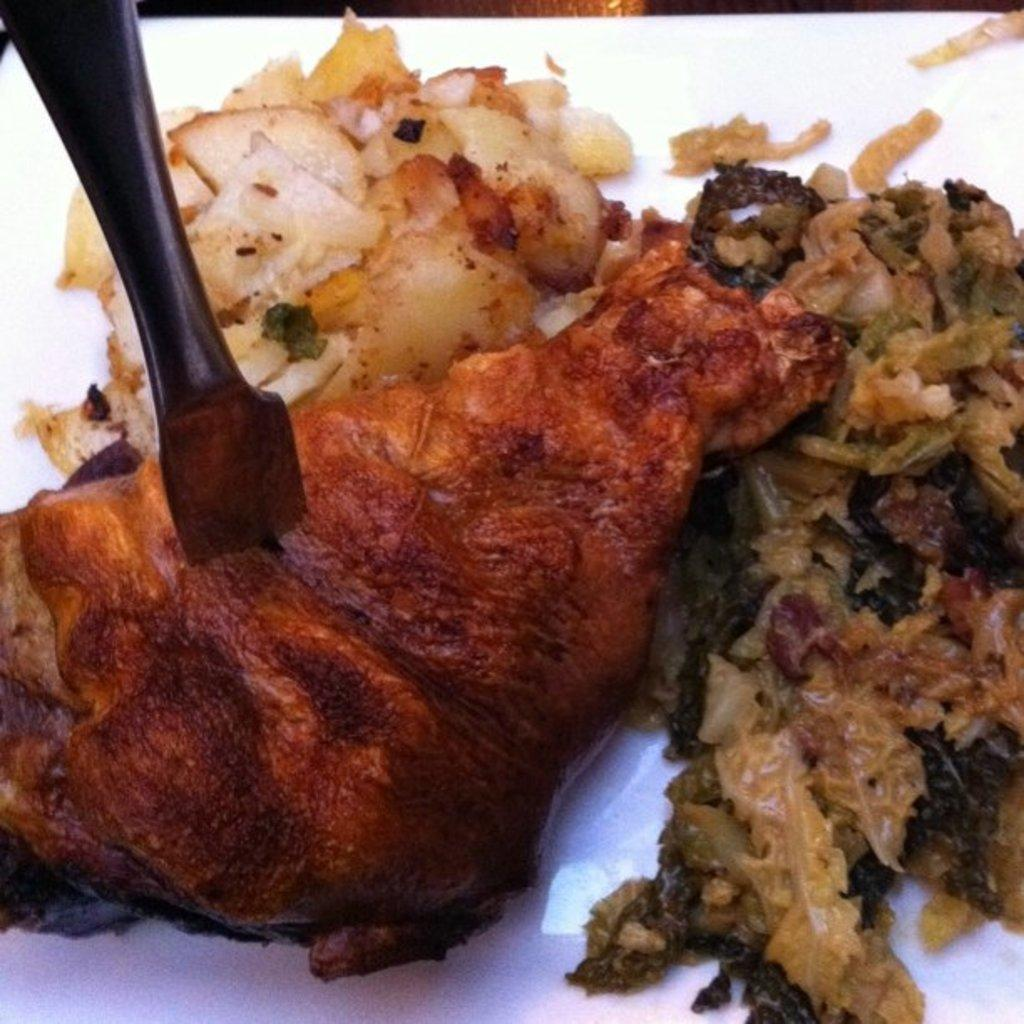What is present on the plate in the image? There are food items kept in a plate in the image. What type of sign can be seen in the sand in the image? There is no sign or sand present in the image; it features a plate with food items. 